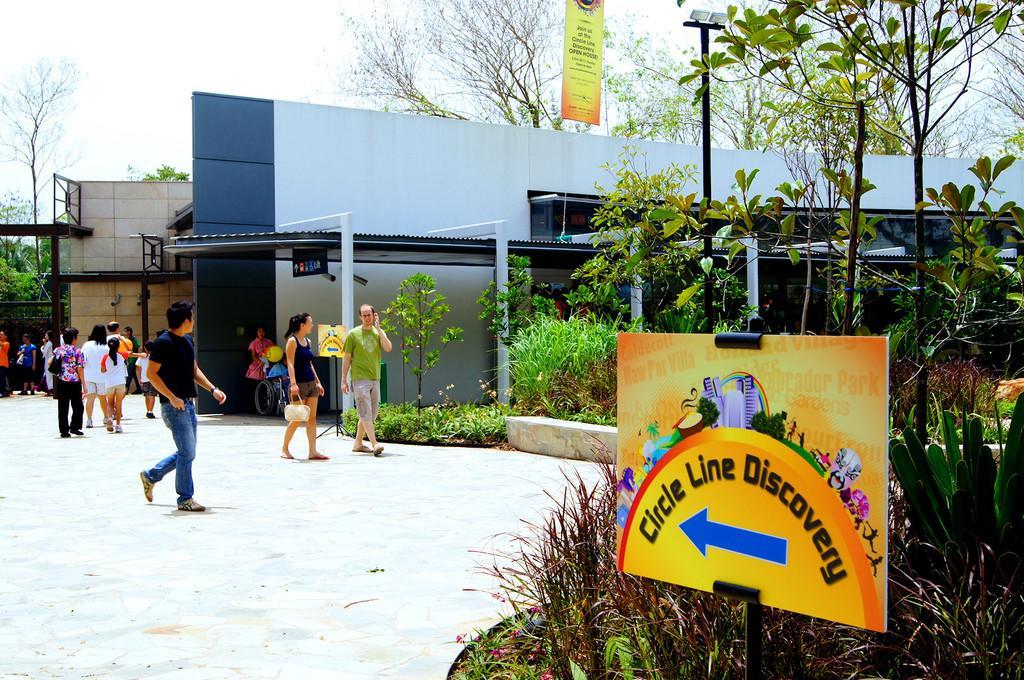How would you summarize this image in a sentence or two? In the image there is a direction board at the entrance and behind that board there are few plants and trees and there are many people walking on the pavement beside some building. In the background there are trees. 